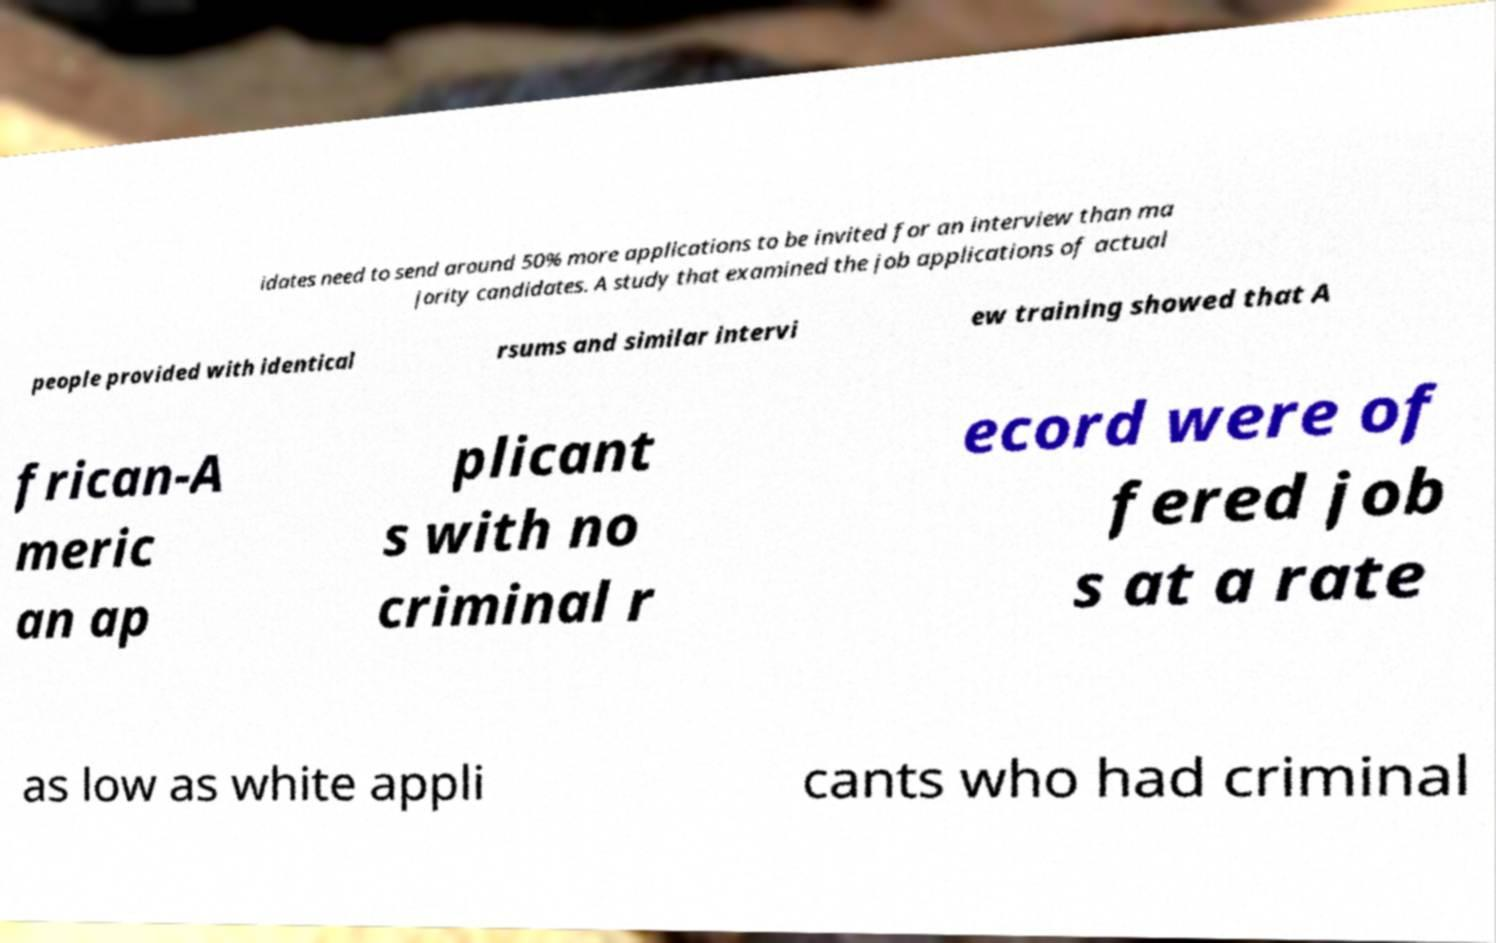I need the written content from this picture converted into text. Can you do that? idates need to send around 50% more applications to be invited for an interview than ma jority candidates. A study that examined the job applications of actual people provided with identical rsums and similar intervi ew training showed that A frican-A meric an ap plicant s with no criminal r ecord were of fered job s at a rate as low as white appli cants who had criminal 